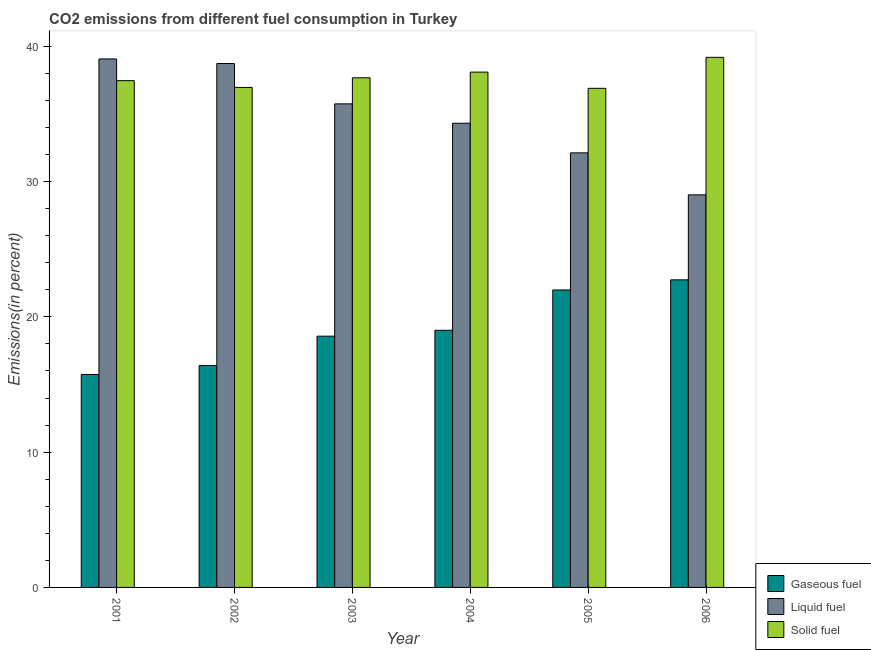How many different coloured bars are there?
Your response must be concise. 3. Are the number of bars on each tick of the X-axis equal?
Ensure brevity in your answer.  Yes. How many bars are there on the 4th tick from the left?
Offer a very short reply. 3. In how many cases, is the number of bars for a given year not equal to the number of legend labels?
Your response must be concise. 0. What is the percentage of solid fuel emission in 2001?
Your answer should be compact. 37.46. Across all years, what is the maximum percentage of liquid fuel emission?
Provide a succinct answer. 39.07. Across all years, what is the minimum percentage of liquid fuel emission?
Offer a very short reply. 29.02. In which year was the percentage of solid fuel emission maximum?
Your response must be concise. 2006. In which year was the percentage of liquid fuel emission minimum?
Make the answer very short. 2006. What is the total percentage of gaseous fuel emission in the graph?
Provide a succinct answer. 114.46. What is the difference between the percentage of gaseous fuel emission in 2004 and that in 2006?
Your answer should be very brief. -3.73. What is the difference between the percentage of solid fuel emission in 2006 and the percentage of liquid fuel emission in 2001?
Keep it short and to the point. 1.72. What is the average percentage of solid fuel emission per year?
Your answer should be very brief. 37.71. In how many years, is the percentage of liquid fuel emission greater than 22 %?
Give a very brief answer. 6. What is the ratio of the percentage of gaseous fuel emission in 2003 to that in 2004?
Provide a succinct answer. 0.98. What is the difference between the highest and the second highest percentage of gaseous fuel emission?
Your response must be concise. 0.75. What is the difference between the highest and the lowest percentage of liquid fuel emission?
Provide a short and direct response. 10.05. In how many years, is the percentage of liquid fuel emission greater than the average percentage of liquid fuel emission taken over all years?
Your answer should be very brief. 3. Is the sum of the percentage of solid fuel emission in 2002 and 2003 greater than the maximum percentage of liquid fuel emission across all years?
Give a very brief answer. Yes. What does the 1st bar from the left in 2002 represents?
Your answer should be compact. Gaseous fuel. What does the 1st bar from the right in 2003 represents?
Offer a very short reply. Solid fuel. What is the difference between two consecutive major ticks on the Y-axis?
Your answer should be very brief. 10. Does the graph contain grids?
Provide a short and direct response. No. Where does the legend appear in the graph?
Ensure brevity in your answer.  Bottom right. How are the legend labels stacked?
Ensure brevity in your answer.  Vertical. What is the title of the graph?
Your answer should be compact. CO2 emissions from different fuel consumption in Turkey. What is the label or title of the X-axis?
Ensure brevity in your answer.  Year. What is the label or title of the Y-axis?
Your answer should be very brief. Emissions(in percent). What is the Emissions(in percent) in Gaseous fuel in 2001?
Ensure brevity in your answer.  15.74. What is the Emissions(in percent) in Liquid fuel in 2001?
Keep it short and to the point. 39.07. What is the Emissions(in percent) of Solid fuel in 2001?
Your answer should be very brief. 37.46. What is the Emissions(in percent) in Gaseous fuel in 2002?
Give a very brief answer. 16.41. What is the Emissions(in percent) in Liquid fuel in 2002?
Provide a succinct answer. 38.73. What is the Emissions(in percent) in Solid fuel in 2002?
Provide a short and direct response. 36.96. What is the Emissions(in percent) of Gaseous fuel in 2003?
Provide a short and direct response. 18.57. What is the Emissions(in percent) in Liquid fuel in 2003?
Your answer should be compact. 35.75. What is the Emissions(in percent) of Solid fuel in 2003?
Give a very brief answer. 37.67. What is the Emissions(in percent) in Gaseous fuel in 2004?
Your answer should be very brief. 19.01. What is the Emissions(in percent) of Liquid fuel in 2004?
Offer a very short reply. 34.31. What is the Emissions(in percent) of Solid fuel in 2004?
Provide a short and direct response. 38.09. What is the Emissions(in percent) in Gaseous fuel in 2005?
Provide a short and direct response. 21.99. What is the Emissions(in percent) of Liquid fuel in 2005?
Ensure brevity in your answer.  32.12. What is the Emissions(in percent) of Solid fuel in 2005?
Keep it short and to the point. 36.9. What is the Emissions(in percent) in Gaseous fuel in 2006?
Your answer should be compact. 22.74. What is the Emissions(in percent) in Liquid fuel in 2006?
Ensure brevity in your answer.  29.02. What is the Emissions(in percent) in Solid fuel in 2006?
Your answer should be compact. 39.19. Across all years, what is the maximum Emissions(in percent) in Gaseous fuel?
Offer a terse response. 22.74. Across all years, what is the maximum Emissions(in percent) in Liquid fuel?
Provide a succinct answer. 39.07. Across all years, what is the maximum Emissions(in percent) in Solid fuel?
Your answer should be compact. 39.19. Across all years, what is the minimum Emissions(in percent) in Gaseous fuel?
Make the answer very short. 15.74. Across all years, what is the minimum Emissions(in percent) in Liquid fuel?
Your answer should be very brief. 29.02. Across all years, what is the minimum Emissions(in percent) in Solid fuel?
Ensure brevity in your answer.  36.9. What is the total Emissions(in percent) in Gaseous fuel in the graph?
Provide a short and direct response. 114.46. What is the total Emissions(in percent) in Liquid fuel in the graph?
Your answer should be very brief. 209. What is the total Emissions(in percent) in Solid fuel in the graph?
Provide a succinct answer. 226.27. What is the difference between the Emissions(in percent) in Gaseous fuel in 2001 and that in 2002?
Your answer should be compact. -0.67. What is the difference between the Emissions(in percent) of Liquid fuel in 2001 and that in 2002?
Your answer should be compact. 0.34. What is the difference between the Emissions(in percent) of Solid fuel in 2001 and that in 2002?
Offer a very short reply. 0.5. What is the difference between the Emissions(in percent) of Gaseous fuel in 2001 and that in 2003?
Ensure brevity in your answer.  -2.83. What is the difference between the Emissions(in percent) in Liquid fuel in 2001 and that in 2003?
Your answer should be very brief. 3.32. What is the difference between the Emissions(in percent) in Solid fuel in 2001 and that in 2003?
Your response must be concise. -0.21. What is the difference between the Emissions(in percent) in Gaseous fuel in 2001 and that in 2004?
Offer a terse response. -3.27. What is the difference between the Emissions(in percent) in Liquid fuel in 2001 and that in 2004?
Offer a terse response. 4.75. What is the difference between the Emissions(in percent) of Solid fuel in 2001 and that in 2004?
Provide a succinct answer. -0.63. What is the difference between the Emissions(in percent) of Gaseous fuel in 2001 and that in 2005?
Offer a terse response. -6.25. What is the difference between the Emissions(in percent) in Liquid fuel in 2001 and that in 2005?
Your answer should be very brief. 6.95. What is the difference between the Emissions(in percent) of Solid fuel in 2001 and that in 2005?
Your response must be concise. 0.57. What is the difference between the Emissions(in percent) in Gaseous fuel in 2001 and that in 2006?
Offer a terse response. -7. What is the difference between the Emissions(in percent) of Liquid fuel in 2001 and that in 2006?
Your answer should be very brief. 10.05. What is the difference between the Emissions(in percent) in Solid fuel in 2001 and that in 2006?
Provide a short and direct response. -1.72. What is the difference between the Emissions(in percent) of Gaseous fuel in 2002 and that in 2003?
Offer a very short reply. -2.17. What is the difference between the Emissions(in percent) in Liquid fuel in 2002 and that in 2003?
Make the answer very short. 2.98. What is the difference between the Emissions(in percent) of Solid fuel in 2002 and that in 2003?
Your response must be concise. -0.71. What is the difference between the Emissions(in percent) in Gaseous fuel in 2002 and that in 2004?
Your response must be concise. -2.6. What is the difference between the Emissions(in percent) of Liquid fuel in 2002 and that in 2004?
Provide a succinct answer. 4.41. What is the difference between the Emissions(in percent) of Solid fuel in 2002 and that in 2004?
Offer a terse response. -1.13. What is the difference between the Emissions(in percent) in Gaseous fuel in 2002 and that in 2005?
Give a very brief answer. -5.58. What is the difference between the Emissions(in percent) in Liquid fuel in 2002 and that in 2005?
Ensure brevity in your answer.  6.6. What is the difference between the Emissions(in percent) in Solid fuel in 2002 and that in 2005?
Your answer should be very brief. 0.07. What is the difference between the Emissions(in percent) in Gaseous fuel in 2002 and that in 2006?
Offer a very short reply. -6.33. What is the difference between the Emissions(in percent) in Liquid fuel in 2002 and that in 2006?
Provide a succinct answer. 9.71. What is the difference between the Emissions(in percent) of Solid fuel in 2002 and that in 2006?
Give a very brief answer. -2.23. What is the difference between the Emissions(in percent) in Gaseous fuel in 2003 and that in 2004?
Your answer should be very brief. -0.44. What is the difference between the Emissions(in percent) of Liquid fuel in 2003 and that in 2004?
Your answer should be very brief. 1.43. What is the difference between the Emissions(in percent) of Solid fuel in 2003 and that in 2004?
Make the answer very short. -0.42. What is the difference between the Emissions(in percent) of Gaseous fuel in 2003 and that in 2005?
Your answer should be compact. -3.42. What is the difference between the Emissions(in percent) of Liquid fuel in 2003 and that in 2005?
Your answer should be compact. 3.62. What is the difference between the Emissions(in percent) in Solid fuel in 2003 and that in 2005?
Your answer should be very brief. 0.78. What is the difference between the Emissions(in percent) of Gaseous fuel in 2003 and that in 2006?
Offer a very short reply. -4.17. What is the difference between the Emissions(in percent) of Liquid fuel in 2003 and that in 2006?
Keep it short and to the point. 6.73. What is the difference between the Emissions(in percent) of Solid fuel in 2003 and that in 2006?
Provide a succinct answer. -1.51. What is the difference between the Emissions(in percent) of Gaseous fuel in 2004 and that in 2005?
Your answer should be very brief. -2.98. What is the difference between the Emissions(in percent) in Liquid fuel in 2004 and that in 2005?
Your response must be concise. 2.19. What is the difference between the Emissions(in percent) in Solid fuel in 2004 and that in 2005?
Ensure brevity in your answer.  1.2. What is the difference between the Emissions(in percent) of Gaseous fuel in 2004 and that in 2006?
Your answer should be compact. -3.73. What is the difference between the Emissions(in percent) in Liquid fuel in 2004 and that in 2006?
Offer a very short reply. 5.3. What is the difference between the Emissions(in percent) of Solid fuel in 2004 and that in 2006?
Offer a very short reply. -1.09. What is the difference between the Emissions(in percent) in Gaseous fuel in 2005 and that in 2006?
Your response must be concise. -0.75. What is the difference between the Emissions(in percent) of Liquid fuel in 2005 and that in 2006?
Your answer should be compact. 3.1. What is the difference between the Emissions(in percent) of Solid fuel in 2005 and that in 2006?
Your answer should be compact. -2.29. What is the difference between the Emissions(in percent) of Gaseous fuel in 2001 and the Emissions(in percent) of Liquid fuel in 2002?
Your response must be concise. -22.99. What is the difference between the Emissions(in percent) in Gaseous fuel in 2001 and the Emissions(in percent) in Solid fuel in 2002?
Provide a short and direct response. -21.22. What is the difference between the Emissions(in percent) in Liquid fuel in 2001 and the Emissions(in percent) in Solid fuel in 2002?
Offer a very short reply. 2.11. What is the difference between the Emissions(in percent) in Gaseous fuel in 2001 and the Emissions(in percent) in Liquid fuel in 2003?
Provide a succinct answer. -20. What is the difference between the Emissions(in percent) of Gaseous fuel in 2001 and the Emissions(in percent) of Solid fuel in 2003?
Offer a terse response. -21.93. What is the difference between the Emissions(in percent) in Liquid fuel in 2001 and the Emissions(in percent) in Solid fuel in 2003?
Give a very brief answer. 1.39. What is the difference between the Emissions(in percent) of Gaseous fuel in 2001 and the Emissions(in percent) of Liquid fuel in 2004?
Your answer should be very brief. -18.57. What is the difference between the Emissions(in percent) of Gaseous fuel in 2001 and the Emissions(in percent) of Solid fuel in 2004?
Make the answer very short. -22.35. What is the difference between the Emissions(in percent) of Liquid fuel in 2001 and the Emissions(in percent) of Solid fuel in 2004?
Provide a short and direct response. 0.98. What is the difference between the Emissions(in percent) in Gaseous fuel in 2001 and the Emissions(in percent) in Liquid fuel in 2005?
Ensure brevity in your answer.  -16.38. What is the difference between the Emissions(in percent) of Gaseous fuel in 2001 and the Emissions(in percent) of Solid fuel in 2005?
Offer a terse response. -21.15. What is the difference between the Emissions(in percent) of Liquid fuel in 2001 and the Emissions(in percent) of Solid fuel in 2005?
Keep it short and to the point. 2.17. What is the difference between the Emissions(in percent) of Gaseous fuel in 2001 and the Emissions(in percent) of Liquid fuel in 2006?
Ensure brevity in your answer.  -13.28. What is the difference between the Emissions(in percent) of Gaseous fuel in 2001 and the Emissions(in percent) of Solid fuel in 2006?
Give a very brief answer. -23.44. What is the difference between the Emissions(in percent) in Liquid fuel in 2001 and the Emissions(in percent) in Solid fuel in 2006?
Your response must be concise. -0.12. What is the difference between the Emissions(in percent) in Gaseous fuel in 2002 and the Emissions(in percent) in Liquid fuel in 2003?
Make the answer very short. -19.34. What is the difference between the Emissions(in percent) of Gaseous fuel in 2002 and the Emissions(in percent) of Solid fuel in 2003?
Give a very brief answer. -21.27. What is the difference between the Emissions(in percent) of Liquid fuel in 2002 and the Emissions(in percent) of Solid fuel in 2003?
Offer a very short reply. 1.05. What is the difference between the Emissions(in percent) in Gaseous fuel in 2002 and the Emissions(in percent) in Liquid fuel in 2004?
Offer a very short reply. -17.91. What is the difference between the Emissions(in percent) in Gaseous fuel in 2002 and the Emissions(in percent) in Solid fuel in 2004?
Offer a terse response. -21.69. What is the difference between the Emissions(in percent) of Liquid fuel in 2002 and the Emissions(in percent) of Solid fuel in 2004?
Offer a very short reply. 0.64. What is the difference between the Emissions(in percent) in Gaseous fuel in 2002 and the Emissions(in percent) in Liquid fuel in 2005?
Your answer should be compact. -15.72. What is the difference between the Emissions(in percent) of Gaseous fuel in 2002 and the Emissions(in percent) of Solid fuel in 2005?
Your response must be concise. -20.49. What is the difference between the Emissions(in percent) in Liquid fuel in 2002 and the Emissions(in percent) in Solid fuel in 2005?
Give a very brief answer. 1.83. What is the difference between the Emissions(in percent) of Gaseous fuel in 2002 and the Emissions(in percent) of Liquid fuel in 2006?
Offer a terse response. -12.61. What is the difference between the Emissions(in percent) in Gaseous fuel in 2002 and the Emissions(in percent) in Solid fuel in 2006?
Your response must be concise. -22.78. What is the difference between the Emissions(in percent) in Liquid fuel in 2002 and the Emissions(in percent) in Solid fuel in 2006?
Provide a short and direct response. -0.46. What is the difference between the Emissions(in percent) in Gaseous fuel in 2003 and the Emissions(in percent) in Liquid fuel in 2004?
Your answer should be very brief. -15.74. What is the difference between the Emissions(in percent) in Gaseous fuel in 2003 and the Emissions(in percent) in Solid fuel in 2004?
Give a very brief answer. -19.52. What is the difference between the Emissions(in percent) of Liquid fuel in 2003 and the Emissions(in percent) of Solid fuel in 2004?
Offer a terse response. -2.35. What is the difference between the Emissions(in percent) in Gaseous fuel in 2003 and the Emissions(in percent) in Liquid fuel in 2005?
Provide a succinct answer. -13.55. What is the difference between the Emissions(in percent) of Gaseous fuel in 2003 and the Emissions(in percent) of Solid fuel in 2005?
Keep it short and to the point. -18.32. What is the difference between the Emissions(in percent) of Liquid fuel in 2003 and the Emissions(in percent) of Solid fuel in 2005?
Provide a short and direct response. -1.15. What is the difference between the Emissions(in percent) in Gaseous fuel in 2003 and the Emissions(in percent) in Liquid fuel in 2006?
Provide a short and direct response. -10.45. What is the difference between the Emissions(in percent) in Gaseous fuel in 2003 and the Emissions(in percent) in Solid fuel in 2006?
Keep it short and to the point. -20.61. What is the difference between the Emissions(in percent) in Liquid fuel in 2003 and the Emissions(in percent) in Solid fuel in 2006?
Your answer should be very brief. -3.44. What is the difference between the Emissions(in percent) of Gaseous fuel in 2004 and the Emissions(in percent) of Liquid fuel in 2005?
Your answer should be compact. -13.12. What is the difference between the Emissions(in percent) in Gaseous fuel in 2004 and the Emissions(in percent) in Solid fuel in 2005?
Provide a short and direct response. -17.89. What is the difference between the Emissions(in percent) of Liquid fuel in 2004 and the Emissions(in percent) of Solid fuel in 2005?
Give a very brief answer. -2.58. What is the difference between the Emissions(in percent) in Gaseous fuel in 2004 and the Emissions(in percent) in Liquid fuel in 2006?
Your response must be concise. -10.01. What is the difference between the Emissions(in percent) in Gaseous fuel in 2004 and the Emissions(in percent) in Solid fuel in 2006?
Ensure brevity in your answer.  -20.18. What is the difference between the Emissions(in percent) in Liquid fuel in 2004 and the Emissions(in percent) in Solid fuel in 2006?
Provide a succinct answer. -4.87. What is the difference between the Emissions(in percent) in Gaseous fuel in 2005 and the Emissions(in percent) in Liquid fuel in 2006?
Offer a terse response. -7.03. What is the difference between the Emissions(in percent) in Gaseous fuel in 2005 and the Emissions(in percent) in Solid fuel in 2006?
Ensure brevity in your answer.  -17.2. What is the difference between the Emissions(in percent) in Liquid fuel in 2005 and the Emissions(in percent) in Solid fuel in 2006?
Ensure brevity in your answer.  -7.06. What is the average Emissions(in percent) of Gaseous fuel per year?
Give a very brief answer. 19.08. What is the average Emissions(in percent) of Liquid fuel per year?
Give a very brief answer. 34.83. What is the average Emissions(in percent) in Solid fuel per year?
Ensure brevity in your answer.  37.71. In the year 2001, what is the difference between the Emissions(in percent) in Gaseous fuel and Emissions(in percent) in Liquid fuel?
Provide a succinct answer. -23.33. In the year 2001, what is the difference between the Emissions(in percent) of Gaseous fuel and Emissions(in percent) of Solid fuel?
Provide a short and direct response. -21.72. In the year 2001, what is the difference between the Emissions(in percent) in Liquid fuel and Emissions(in percent) in Solid fuel?
Give a very brief answer. 1.61. In the year 2002, what is the difference between the Emissions(in percent) of Gaseous fuel and Emissions(in percent) of Liquid fuel?
Your response must be concise. -22.32. In the year 2002, what is the difference between the Emissions(in percent) of Gaseous fuel and Emissions(in percent) of Solid fuel?
Your response must be concise. -20.55. In the year 2002, what is the difference between the Emissions(in percent) in Liquid fuel and Emissions(in percent) in Solid fuel?
Offer a very short reply. 1.77. In the year 2003, what is the difference between the Emissions(in percent) in Gaseous fuel and Emissions(in percent) in Liquid fuel?
Keep it short and to the point. -17.17. In the year 2003, what is the difference between the Emissions(in percent) in Gaseous fuel and Emissions(in percent) in Solid fuel?
Provide a succinct answer. -19.1. In the year 2003, what is the difference between the Emissions(in percent) of Liquid fuel and Emissions(in percent) of Solid fuel?
Offer a very short reply. -1.93. In the year 2004, what is the difference between the Emissions(in percent) in Gaseous fuel and Emissions(in percent) in Liquid fuel?
Your answer should be compact. -15.31. In the year 2004, what is the difference between the Emissions(in percent) in Gaseous fuel and Emissions(in percent) in Solid fuel?
Give a very brief answer. -19.08. In the year 2004, what is the difference between the Emissions(in percent) in Liquid fuel and Emissions(in percent) in Solid fuel?
Provide a succinct answer. -3.78. In the year 2005, what is the difference between the Emissions(in percent) of Gaseous fuel and Emissions(in percent) of Liquid fuel?
Offer a very short reply. -10.13. In the year 2005, what is the difference between the Emissions(in percent) in Gaseous fuel and Emissions(in percent) in Solid fuel?
Give a very brief answer. -14.91. In the year 2005, what is the difference between the Emissions(in percent) of Liquid fuel and Emissions(in percent) of Solid fuel?
Your answer should be very brief. -4.77. In the year 2006, what is the difference between the Emissions(in percent) in Gaseous fuel and Emissions(in percent) in Liquid fuel?
Ensure brevity in your answer.  -6.28. In the year 2006, what is the difference between the Emissions(in percent) of Gaseous fuel and Emissions(in percent) of Solid fuel?
Your answer should be very brief. -16.45. In the year 2006, what is the difference between the Emissions(in percent) of Liquid fuel and Emissions(in percent) of Solid fuel?
Your answer should be compact. -10.17. What is the ratio of the Emissions(in percent) of Gaseous fuel in 2001 to that in 2002?
Ensure brevity in your answer.  0.96. What is the ratio of the Emissions(in percent) in Liquid fuel in 2001 to that in 2002?
Your response must be concise. 1.01. What is the ratio of the Emissions(in percent) in Solid fuel in 2001 to that in 2002?
Your response must be concise. 1.01. What is the ratio of the Emissions(in percent) of Gaseous fuel in 2001 to that in 2003?
Provide a short and direct response. 0.85. What is the ratio of the Emissions(in percent) in Liquid fuel in 2001 to that in 2003?
Provide a short and direct response. 1.09. What is the ratio of the Emissions(in percent) in Gaseous fuel in 2001 to that in 2004?
Offer a very short reply. 0.83. What is the ratio of the Emissions(in percent) in Liquid fuel in 2001 to that in 2004?
Offer a terse response. 1.14. What is the ratio of the Emissions(in percent) in Solid fuel in 2001 to that in 2004?
Provide a succinct answer. 0.98. What is the ratio of the Emissions(in percent) of Gaseous fuel in 2001 to that in 2005?
Offer a very short reply. 0.72. What is the ratio of the Emissions(in percent) of Liquid fuel in 2001 to that in 2005?
Offer a very short reply. 1.22. What is the ratio of the Emissions(in percent) of Solid fuel in 2001 to that in 2005?
Offer a very short reply. 1.02. What is the ratio of the Emissions(in percent) of Gaseous fuel in 2001 to that in 2006?
Make the answer very short. 0.69. What is the ratio of the Emissions(in percent) of Liquid fuel in 2001 to that in 2006?
Ensure brevity in your answer.  1.35. What is the ratio of the Emissions(in percent) of Solid fuel in 2001 to that in 2006?
Offer a very short reply. 0.96. What is the ratio of the Emissions(in percent) in Gaseous fuel in 2002 to that in 2003?
Offer a very short reply. 0.88. What is the ratio of the Emissions(in percent) in Liquid fuel in 2002 to that in 2003?
Ensure brevity in your answer.  1.08. What is the ratio of the Emissions(in percent) of Solid fuel in 2002 to that in 2003?
Provide a short and direct response. 0.98. What is the ratio of the Emissions(in percent) in Gaseous fuel in 2002 to that in 2004?
Provide a short and direct response. 0.86. What is the ratio of the Emissions(in percent) in Liquid fuel in 2002 to that in 2004?
Ensure brevity in your answer.  1.13. What is the ratio of the Emissions(in percent) of Solid fuel in 2002 to that in 2004?
Provide a succinct answer. 0.97. What is the ratio of the Emissions(in percent) of Gaseous fuel in 2002 to that in 2005?
Give a very brief answer. 0.75. What is the ratio of the Emissions(in percent) in Liquid fuel in 2002 to that in 2005?
Ensure brevity in your answer.  1.21. What is the ratio of the Emissions(in percent) of Gaseous fuel in 2002 to that in 2006?
Offer a very short reply. 0.72. What is the ratio of the Emissions(in percent) of Liquid fuel in 2002 to that in 2006?
Provide a succinct answer. 1.33. What is the ratio of the Emissions(in percent) of Solid fuel in 2002 to that in 2006?
Give a very brief answer. 0.94. What is the ratio of the Emissions(in percent) in Gaseous fuel in 2003 to that in 2004?
Offer a terse response. 0.98. What is the ratio of the Emissions(in percent) of Liquid fuel in 2003 to that in 2004?
Your answer should be very brief. 1.04. What is the ratio of the Emissions(in percent) of Gaseous fuel in 2003 to that in 2005?
Offer a terse response. 0.84. What is the ratio of the Emissions(in percent) in Liquid fuel in 2003 to that in 2005?
Keep it short and to the point. 1.11. What is the ratio of the Emissions(in percent) of Solid fuel in 2003 to that in 2005?
Your answer should be very brief. 1.02. What is the ratio of the Emissions(in percent) in Gaseous fuel in 2003 to that in 2006?
Offer a very short reply. 0.82. What is the ratio of the Emissions(in percent) in Liquid fuel in 2003 to that in 2006?
Your answer should be compact. 1.23. What is the ratio of the Emissions(in percent) in Solid fuel in 2003 to that in 2006?
Your response must be concise. 0.96. What is the ratio of the Emissions(in percent) of Gaseous fuel in 2004 to that in 2005?
Your answer should be very brief. 0.86. What is the ratio of the Emissions(in percent) in Liquid fuel in 2004 to that in 2005?
Offer a terse response. 1.07. What is the ratio of the Emissions(in percent) in Solid fuel in 2004 to that in 2005?
Make the answer very short. 1.03. What is the ratio of the Emissions(in percent) in Gaseous fuel in 2004 to that in 2006?
Ensure brevity in your answer.  0.84. What is the ratio of the Emissions(in percent) of Liquid fuel in 2004 to that in 2006?
Make the answer very short. 1.18. What is the ratio of the Emissions(in percent) of Solid fuel in 2004 to that in 2006?
Give a very brief answer. 0.97. What is the ratio of the Emissions(in percent) in Gaseous fuel in 2005 to that in 2006?
Ensure brevity in your answer.  0.97. What is the ratio of the Emissions(in percent) of Liquid fuel in 2005 to that in 2006?
Your answer should be very brief. 1.11. What is the ratio of the Emissions(in percent) in Solid fuel in 2005 to that in 2006?
Your response must be concise. 0.94. What is the difference between the highest and the second highest Emissions(in percent) in Gaseous fuel?
Provide a succinct answer. 0.75. What is the difference between the highest and the second highest Emissions(in percent) of Liquid fuel?
Your answer should be compact. 0.34. What is the difference between the highest and the second highest Emissions(in percent) of Solid fuel?
Offer a very short reply. 1.09. What is the difference between the highest and the lowest Emissions(in percent) in Gaseous fuel?
Provide a short and direct response. 7. What is the difference between the highest and the lowest Emissions(in percent) in Liquid fuel?
Keep it short and to the point. 10.05. What is the difference between the highest and the lowest Emissions(in percent) of Solid fuel?
Your response must be concise. 2.29. 